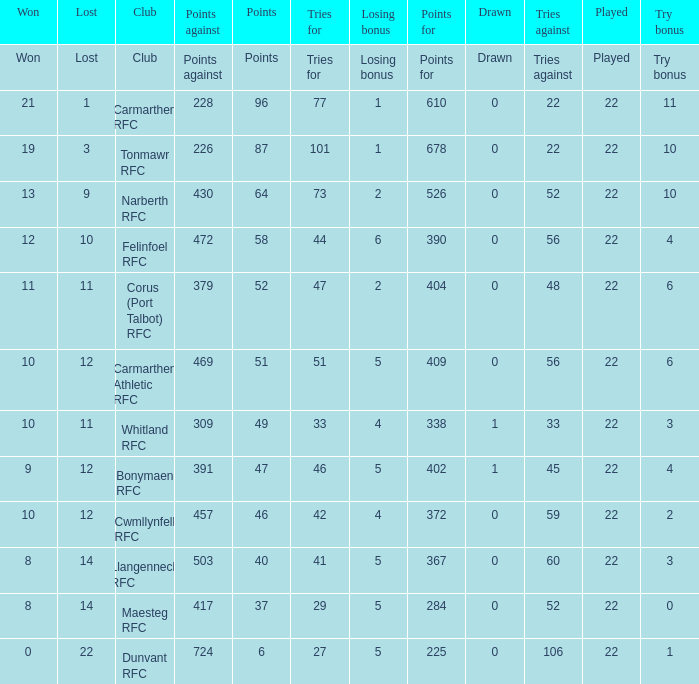Name the losing bonus of 96 points 1.0. 